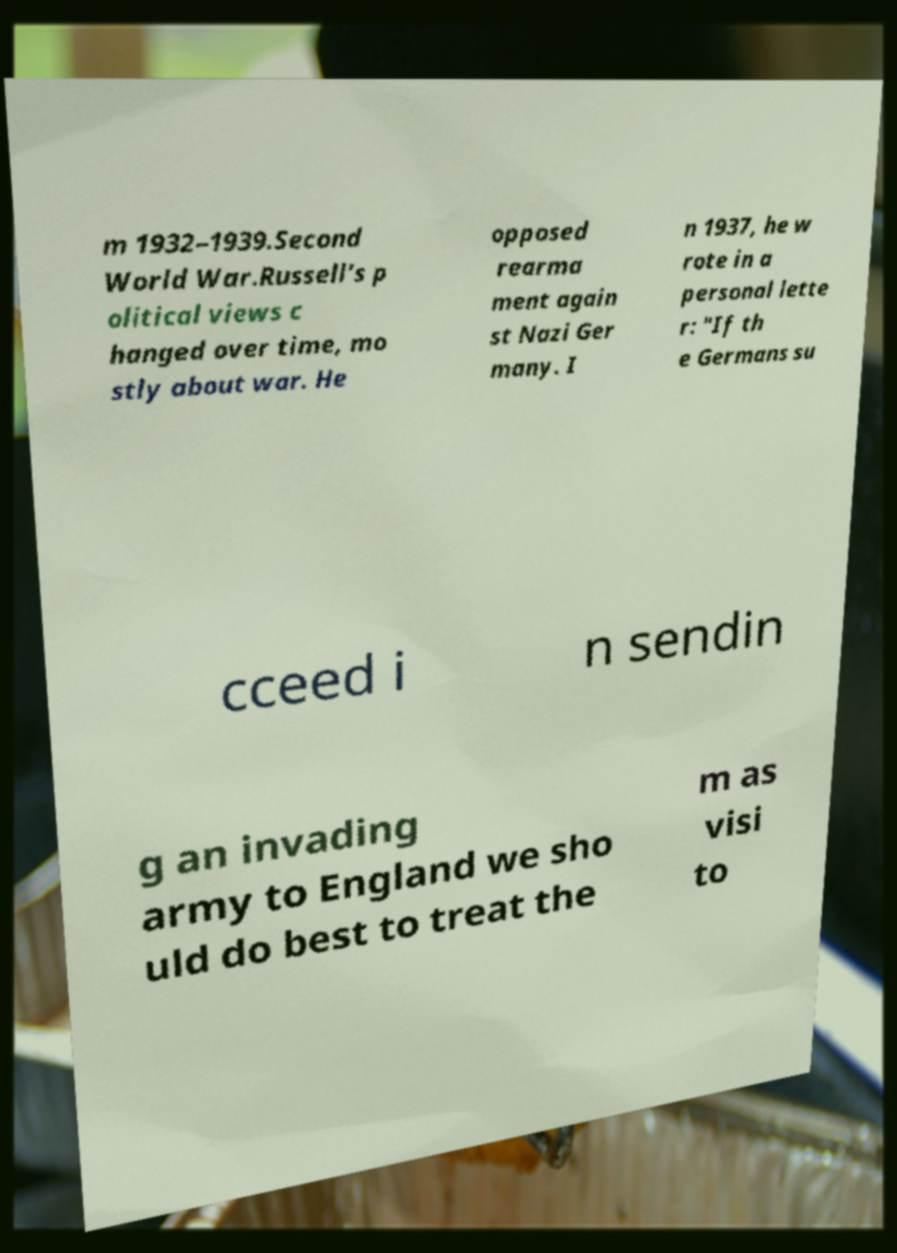For documentation purposes, I need the text within this image transcribed. Could you provide that? m 1932–1939.Second World War.Russell's p olitical views c hanged over time, mo stly about war. He opposed rearma ment again st Nazi Ger many. I n 1937, he w rote in a personal lette r: "If th e Germans su cceed i n sendin g an invading army to England we sho uld do best to treat the m as visi to 